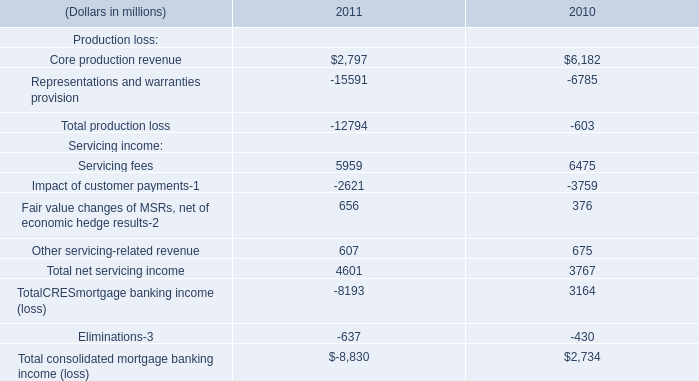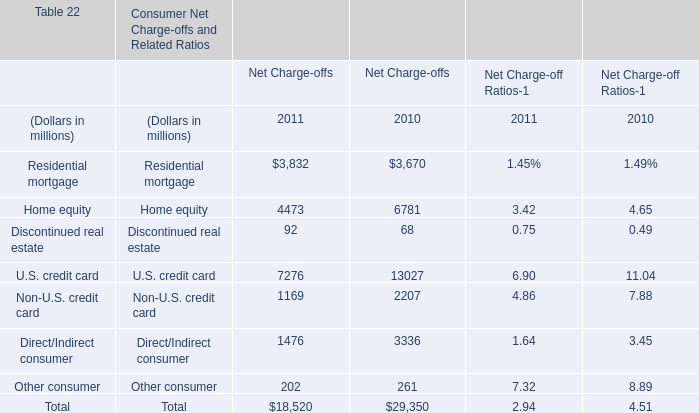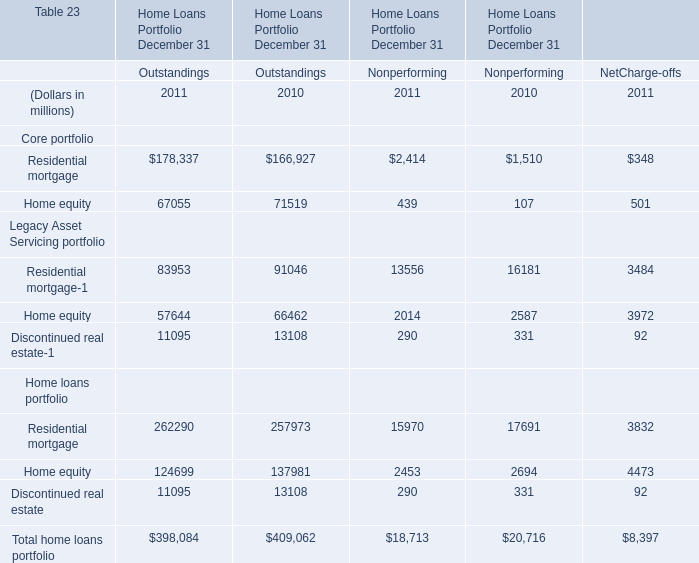What's the total amount of the Home equity in the years where Home equity is greater than 1 for Outstandings ? (in million) 
Computations: (67055 + 71519)
Answer: 138574.0. 